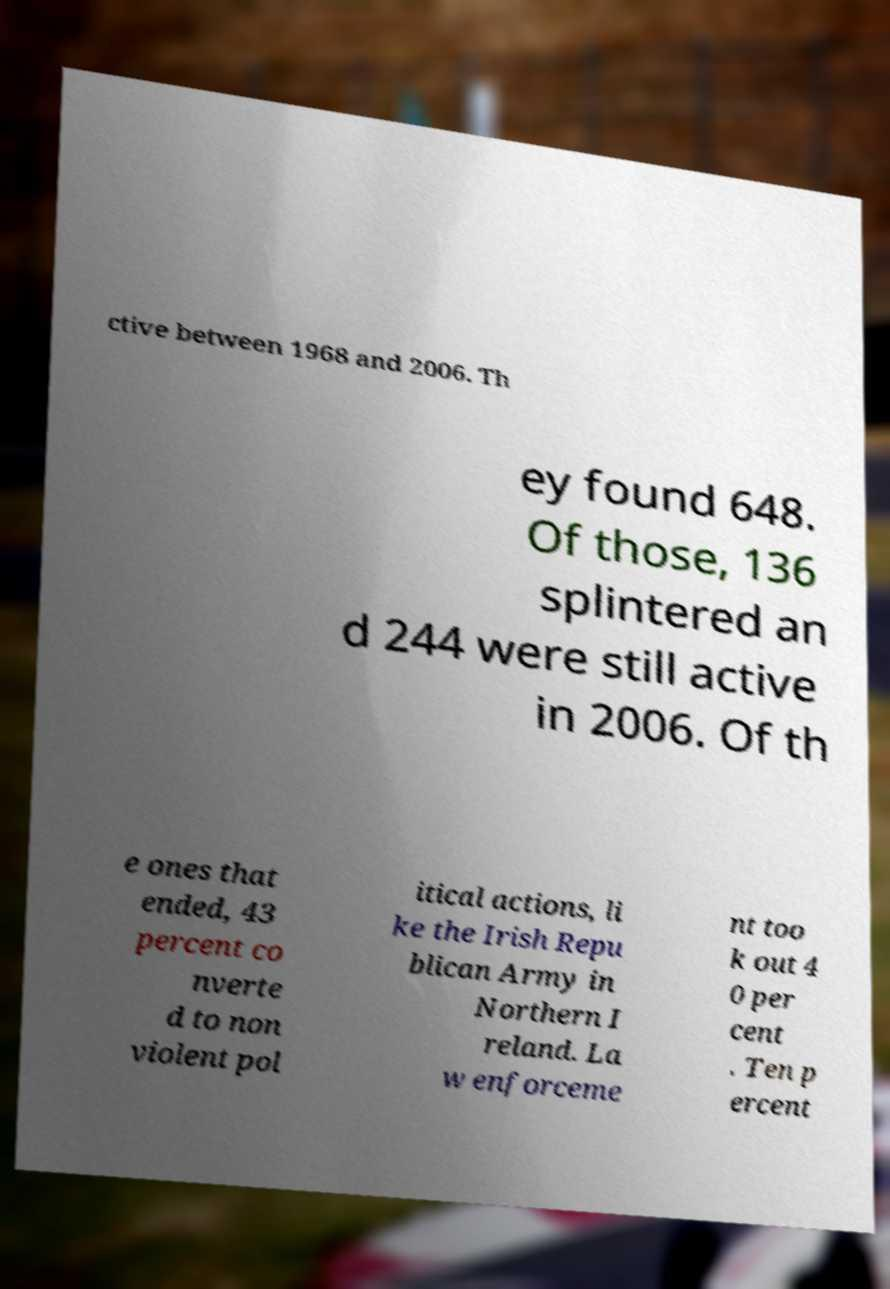Please read and relay the text visible in this image. What does it say? ctive between 1968 and 2006. Th ey found 648. Of those, 136 splintered an d 244 were still active in 2006. Of th e ones that ended, 43 percent co nverte d to non violent pol itical actions, li ke the Irish Repu blican Army in Northern I reland. La w enforceme nt too k out 4 0 per cent . Ten p ercent 